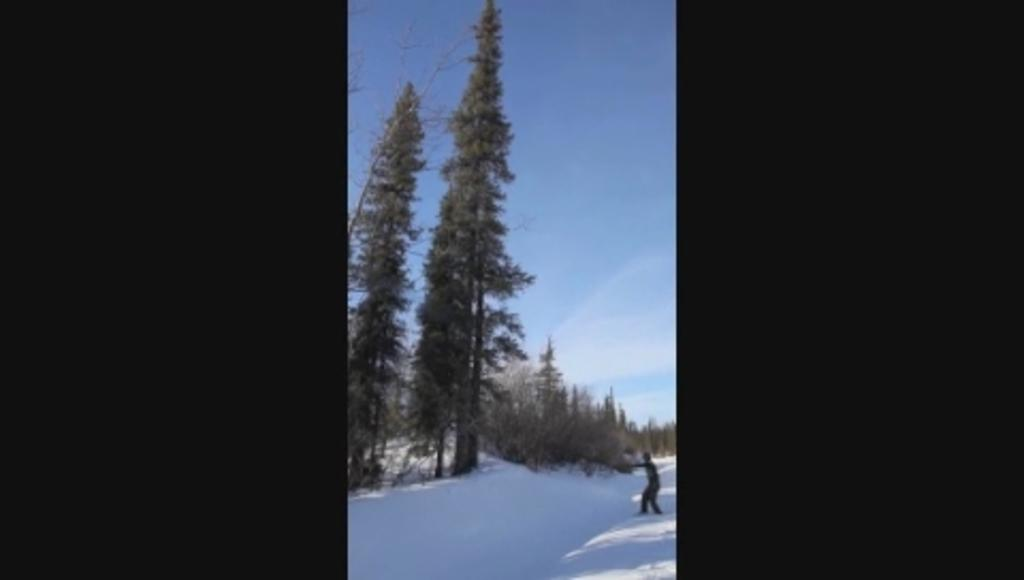What type of surface is visible in the image? The image contains a snow surface. Can you describe the person in the image? There is a person standing in the image. What can be seen in the background of the image? There are trees and the sky visible in the background of the image. What is the condition of the sky in the image? Clouds are present in the sky. What type of leather can be seen on the truck in the image? There is no truck present in the image, so there is no leather to be seen. What trail is visible in the image? There is no trail visible in the image; it features a snow surface, a person, trees, and the sky. 